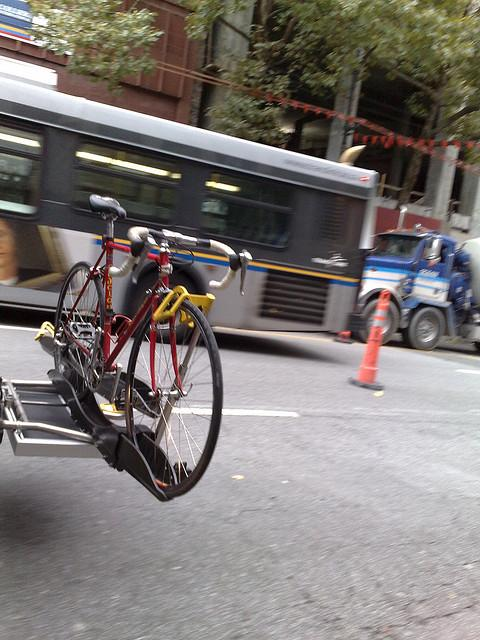What is to the left of the cone? Please explain your reasoning. bicycle. There is a bike on a platform on back of vehicle. 